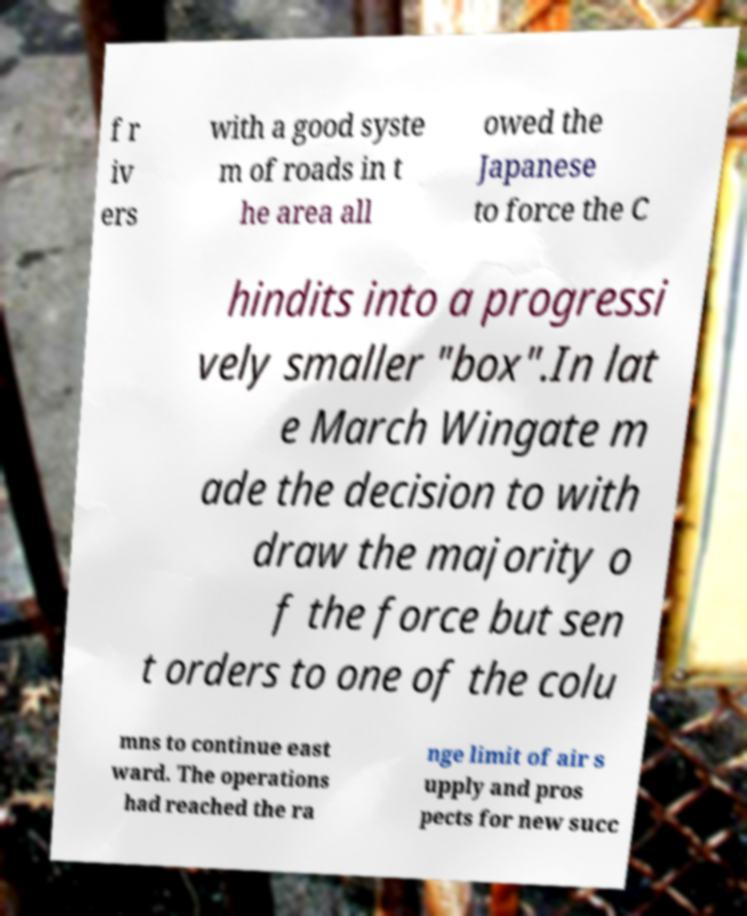Can you read and provide the text displayed in the image?This photo seems to have some interesting text. Can you extract and type it out for me? f r iv ers with a good syste m of roads in t he area all owed the Japanese to force the C hindits into a progressi vely smaller "box".In lat e March Wingate m ade the decision to with draw the majority o f the force but sen t orders to one of the colu mns to continue east ward. The operations had reached the ra nge limit of air s upply and pros pects for new succ 